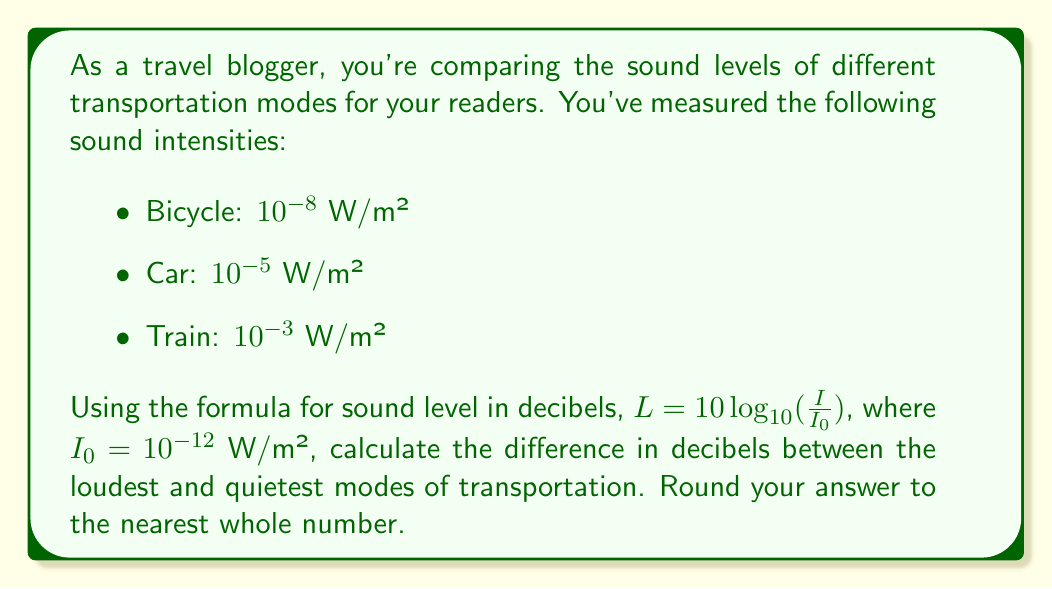Can you answer this question? To solve this problem, we'll follow these steps:

1) First, calculate the sound level in decibels for each mode of transportation using the given formula:

   $L = 10 \log_{10}(\frac{I}{I_0})$

2) For bicycle:
   $L_{bicycle} = 10 \log_{10}(\frac{10^{-8}}{10^{-12}}) = 10 \log_{10}(10^4) = 10 \cdot 4 = 40$ dB

3) For car:
   $L_{car} = 10 \log_{10}(\frac{10^{-5}}{10^{-12}}) = 10 \log_{10}(10^7) = 10 \cdot 7 = 70$ dB

4) For train:
   $L_{train} = 10 \log_{10}(\frac{10^{-3}}{10^{-12}}) = 10 \log_{10}(10^9) = 10 \cdot 9 = 90$ dB

5) The loudest mode is the train (90 dB) and the quietest is the bicycle (40 dB).

6) Calculate the difference:
   $90 - 40 = 50$ dB

Therefore, the difference in decibels between the loudest and quietest modes of transportation is 50 dB.
Answer: 50 dB 